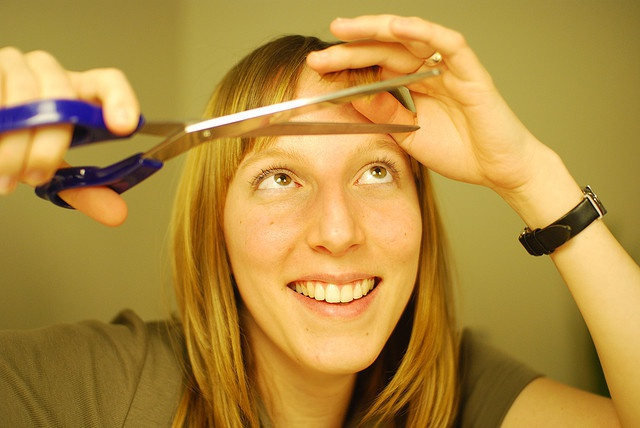Describe the objects in this image and their specific colors. I can see people in olive, orange, and tan tones, scissors in olive, black, and orange tones, and clock in olive and maroon tones in this image. 